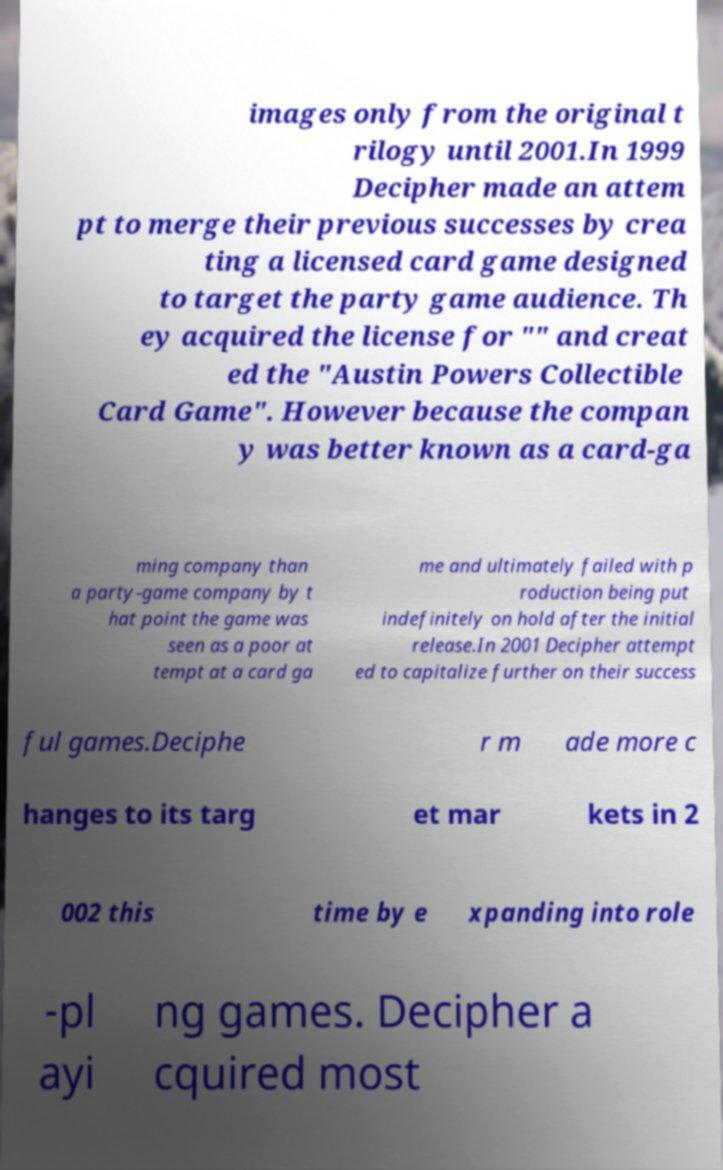Please read and relay the text visible in this image. What does it say? images only from the original t rilogy until 2001.In 1999 Decipher made an attem pt to merge their previous successes by crea ting a licensed card game designed to target the party game audience. Th ey acquired the license for "" and creat ed the "Austin Powers Collectible Card Game". However because the compan y was better known as a card-ga ming company than a party-game company by t hat point the game was seen as a poor at tempt at a card ga me and ultimately failed with p roduction being put indefinitely on hold after the initial release.In 2001 Decipher attempt ed to capitalize further on their success ful games.Deciphe r m ade more c hanges to its targ et mar kets in 2 002 this time by e xpanding into role -pl ayi ng games. Decipher a cquired most 